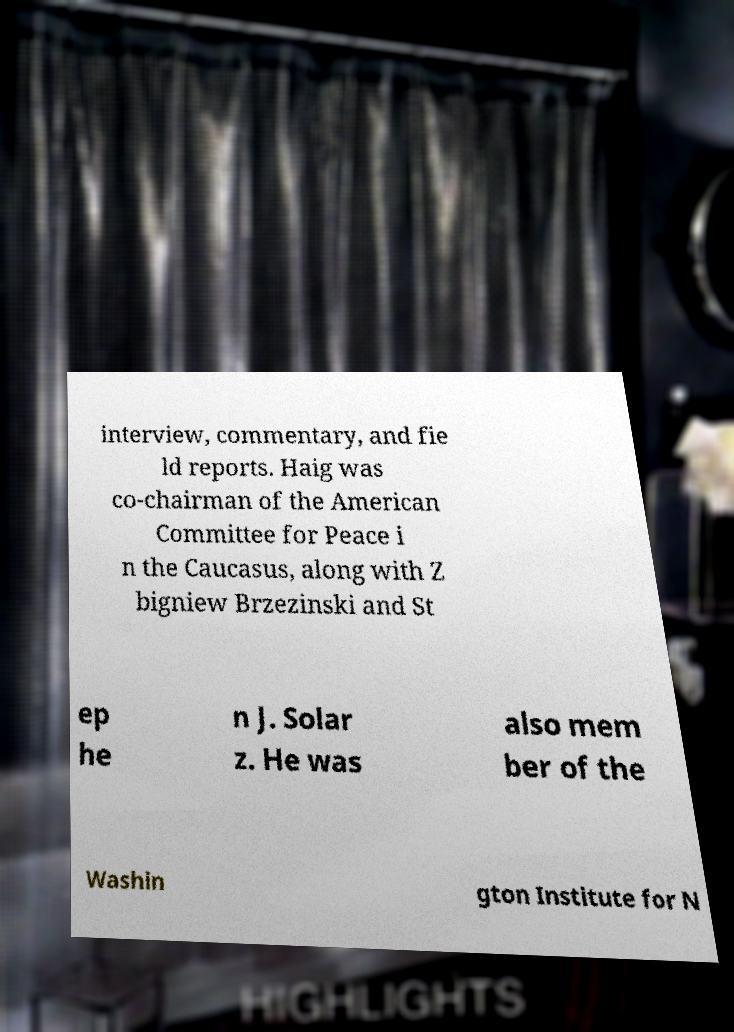Can you read and provide the text displayed in the image?This photo seems to have some interesting text. Can you extract and type it out for me? interview, commentary, and fie ld reports. Haig was co-chairman of the American Committee for Peace i n the Caucasus, along with Z bigniew Brzezinski and St ep he n J. Solar z. He was also mem ber of the Washin gton Institute for N 